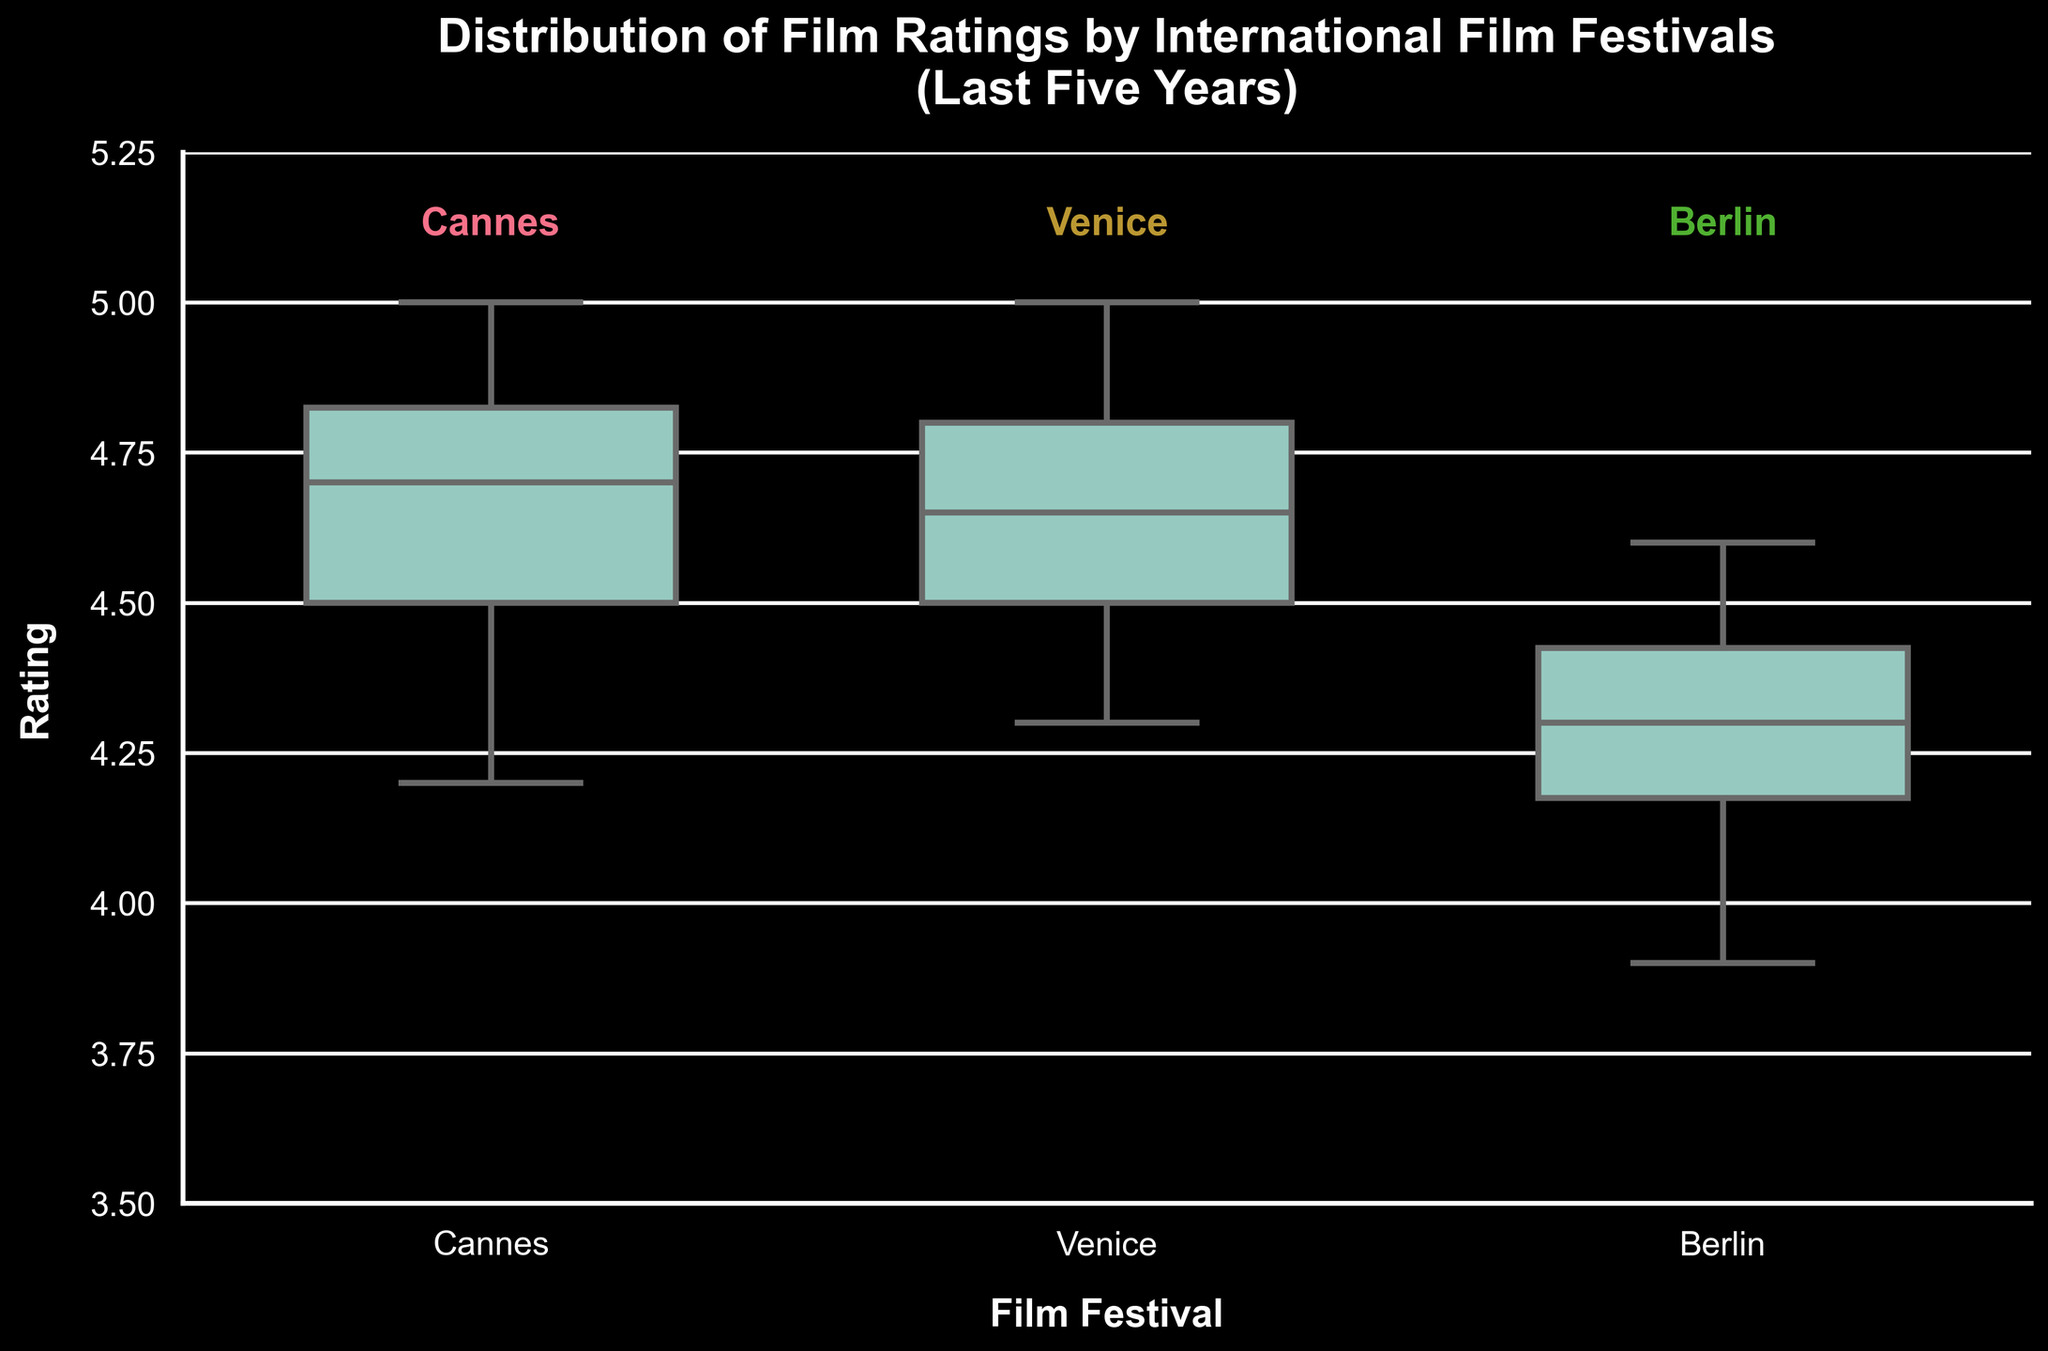What is the title of the figure? The title of the figure is typically displayed at the top of the chart. In this case, it is mentioned explicitly in the provided code.
Answer: Distribution of Film Ratings by International Film Festivals (Last Five Years) Which festival has the widest interquartile range (IQR) in film ratings? The interquartile range (IQR) is the range between the first quartile (Q1) and the third quartile (Q3) in a box plot. By comparing the width of the boxes in the figure, one can determine the festival with the widest IQR.
Answer: Berlin What is the median film rating for Venice? The median is the line inside the box of the box plot. By looking at the box for Venice, the median line indicates the value.
Answer: 4.7 How do the maximum film ratings compare between Cannes and Berlin? The maximum rating is the top whisker of the box plot for each festival. By comparing the lengths of the whiskers for Cannes and Berlin, we find that Cannes has a maximum rating at 5, while Berlin’s maximum rating is lower.
Answer: Cannes: 5, Berlin: 4.6 Which festival has the highest median film rating? By comparing the median lines inside the boxes for each festival, we see which one is higher. Venice has the median line closest to 4.7, higher than Cannes and Berlin.
Answer: Venice How do the minimum ratings of Cannes and Venice compare? The minimum rating is the bottom whisker of the box plot for each festival. Comparing them shows that Venice has a higher minimum rating than Cannes, which has a minimum rating of about 4.2.
Answer: Venice is higher What is the overall range of film ratings seen at Cannes? The overall range is the difference between the maximum and minimum values in the box plot for Cannes. The highest whisker is at 5, and the lowest whisker is around 4.2. So the range is 5 - 4.2.
Answer: 0.8 Which festival has the most concentrated film ratings? Concentration can be judged by the height of the boxes and whiskers. A more concentrated distribution will have a shorter overall height. Cannes appears to have the shortest overall height, indicating the most concentrated ratings.
Answer: Cannes What do the outliers represent in the context of this box plot? In a box plot, outliers are data points that fall outside the typical range (1.5 times the IQR from the boxes). These points represent film ratings that are unusually high or low compared to most ratings.
Answer: Unusually high or low film ratings Are there any outlier ratings for Berlin? Outliers in a box plot are typically represented by individual points outside the whiskers. By looking at Berlin’s box plot, we can check if any points are far from the whiskers.
Answer: No 